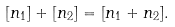<formula> <loc_0><loc_0><loc_500><loc_500>[ n _ { 1 } ] + [ n _ { 2 } ] = [ n _ { 1 } + n _ { 2 } ] .</formula> 